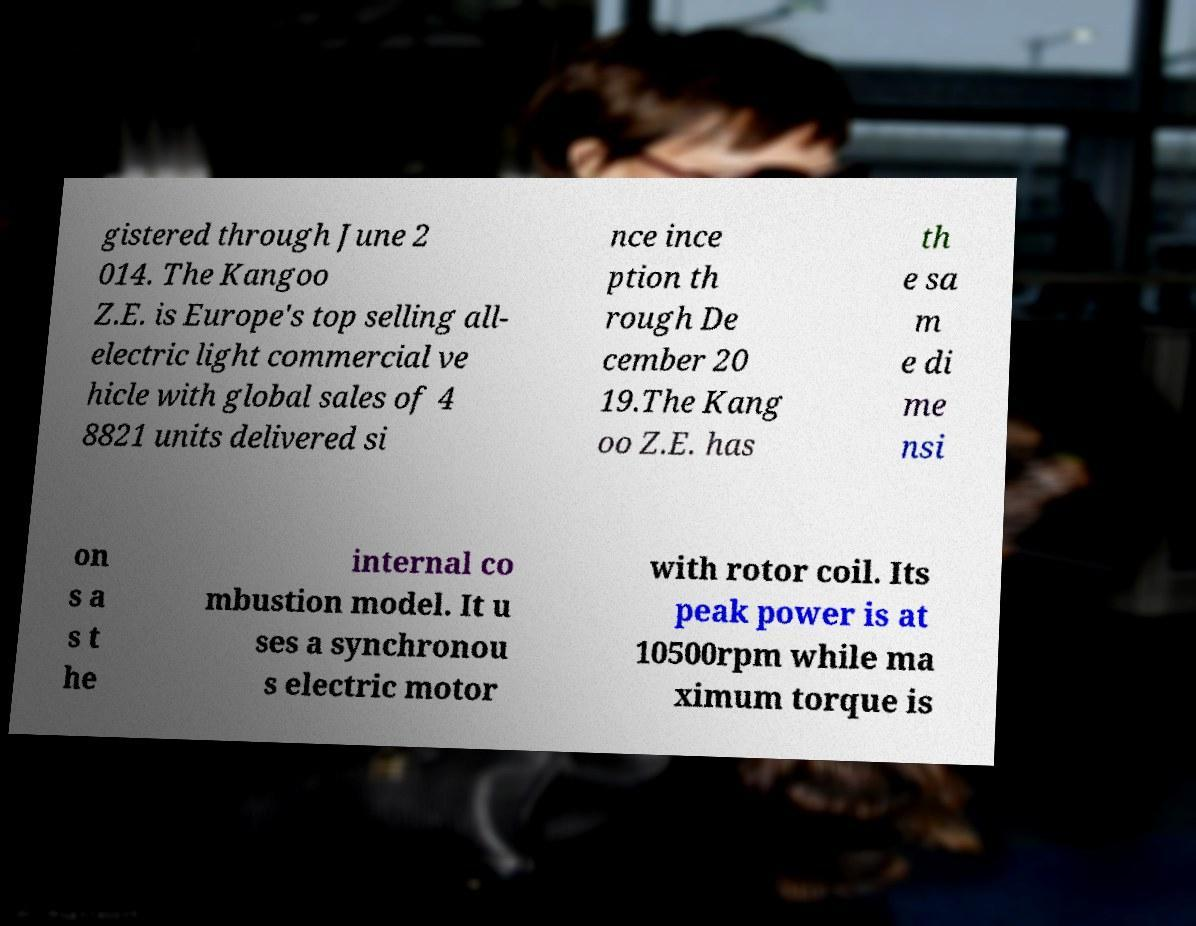Can you accurately transcribe the text from the provided image for me? gistered through June 2 014. The Kangoo Z.E. is Europe's top selling all- electric light commercial ve hicle with global sales of 4 8821 units delivered si nce ince ption th rough De cember 20 19.The Kang oo Z.E. has th e sa m e di me nsi on s a s t he internal co mbustion model. It u ses a synchronou s electric motor with rotor coil. Its peak power is at 10500rpm while ma ximum torque is 